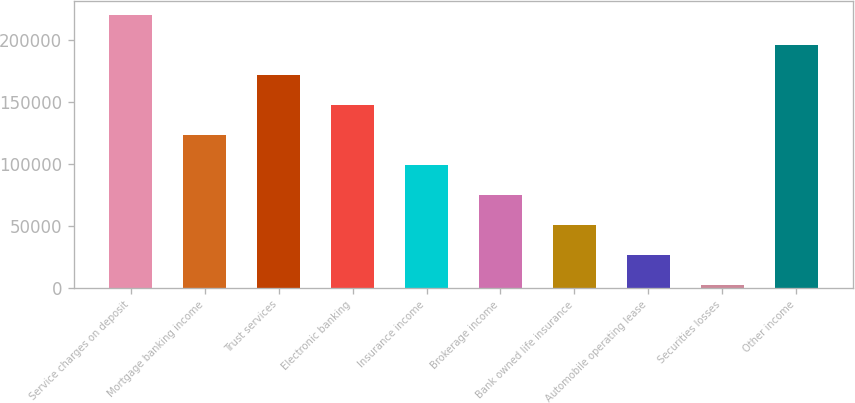Convert chart. <chart><loc_0><loc_0><loc_500><loc_500><bar_chart><fcel>Service charges on deposit<fcel>Mortgage banking income<fcel>Trust services<fcel>Electronic banking<fcel>Insurance income<fcel>Brokerage income<fcel>Bank owned life insurance<fcel>Automobile operating lease<fcel>Securities losses<fcel>Other income<nl><fcel>220352<fcel>123574<fcel>171963<fcel>147768<fcel>99379.6<fcel>75185.2<fcel>50990.8<fcel>26796.4<fcel>2602<fcel>196157<nl></chart> 